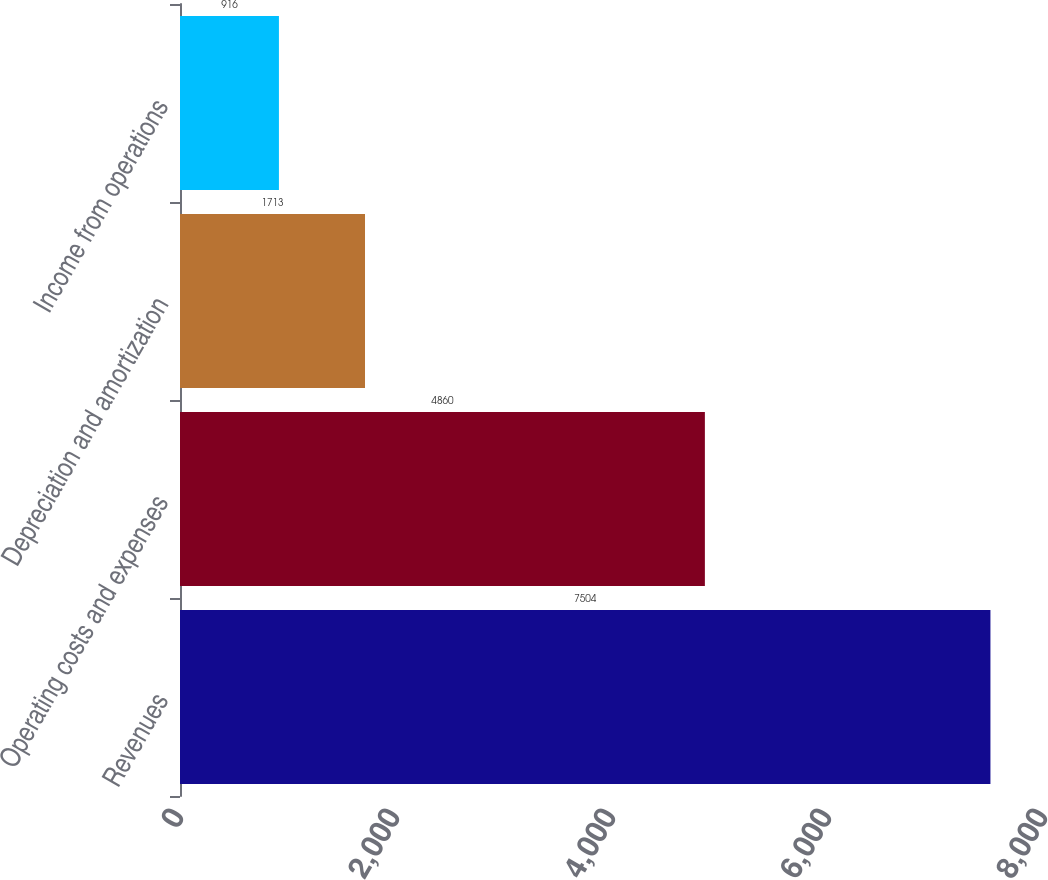<chart> <loc_0><loc_0><loc_500><loc_500><bar_chart><fcel>Revenues<fcel>Operating costs and expenses<fcel>Depreciation and amortization<fcel>Income from operations<nl><fcel>7504<fcel>4860<fcel>1713<fcel>916<nl></chart> 